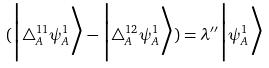<formula> <loc_0><loc_0><loc_500><loc_500>( \Big | \triangle _ { A } ^ { 1 1 } \psi ^ { 1 } _ { A } \Big > - \Big | \triangle _ { A } ^ { 1 2 } \psi ^ { 1 } _ { A } \Big > ) = \lambda ^ { \prime \prime } \Big | \psi ^ { 1 } _ { A } \Big ></formula> 